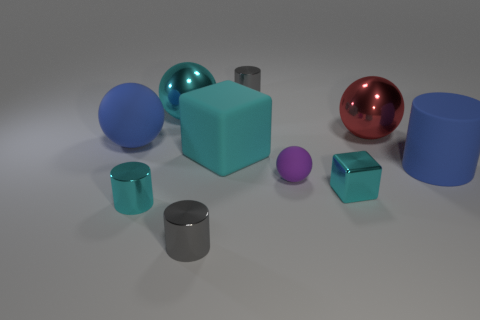There is a block that is the same size as the blue matte sphere; what color is it?
Give a very brief answer. Cyan. What number of things are tiny matte things or tiny cyan metal things?
Give a very brief answer. 3. There is a tiny purple rubber ball; are there any cyan rubber blocks in front of it?
Your answer should be very brief. No. Are there any other tiny brown balls that have the same material as the tiny ball?
Offer a terse response. No. What size is the metallic cylinder that is the same color as the tiny cube?
Provide a short and direct response. Small. What number of blocks are green things or big cyan shiny things?
Your response must be concise. 0. Is the number of tiny matte spheres behind the large blue rubber cylinder greater than the number of big blue rubber objects that are to the left of the red object?
Give a very brief answer. No. What number of spheres have the same color as the matte block?
Provide a succinct answer. 1. What size is the red ball that is the same material as the big cyan sphere?
Make the answer very short. Large. What number of things are either small balls that are to the right of the big cyan metal thing or cylinders?
Give a very brief answer. 5. 